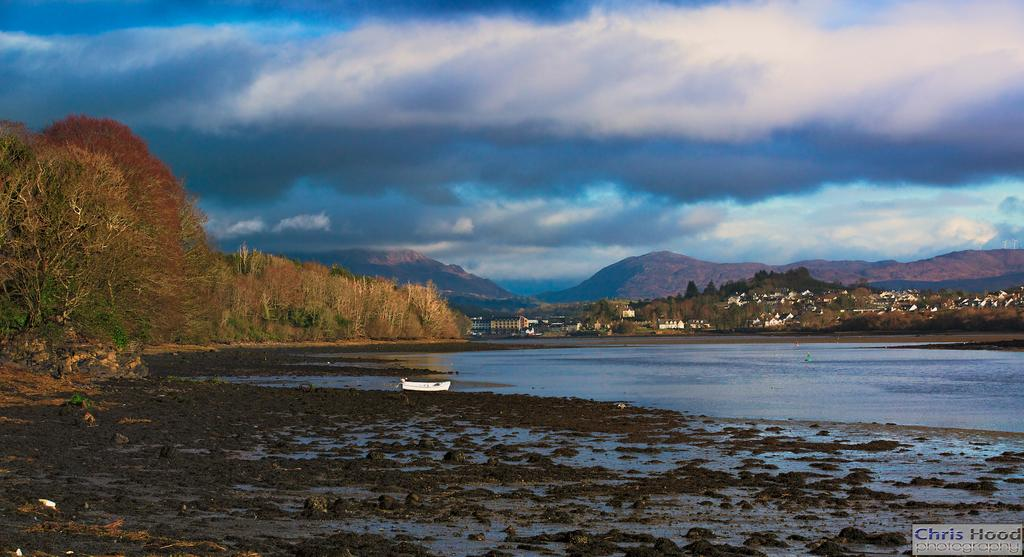What is the primary element visible in the image? There is water in the image. What other natural elements can be seen in the image? There are trees in the image. Are there any man-made structures visible? Yes, there are buildings in the image. What type of geographical feature is present in the image? There are mountains in the image. What can be seen in the background of the image? The sky is visible in the background of the image, and clouds are present in the sky. What type of dinner is being served in the yard in the image? There is no dinner or yard present in the image; it features water, trees, buildings, mountains, and a sky with clouds. 